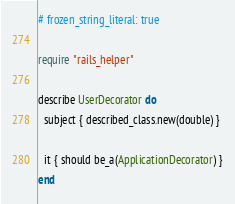<code> <loc_0><loc_0><loc_500><loc_500><_Ruby_># frozen_string_literal: true

require "rails_helper"

describe UserDecorator do
  subject { described_class.new(double) }

  it { should be_a(ApplicationDecorator) }
end
</code> 